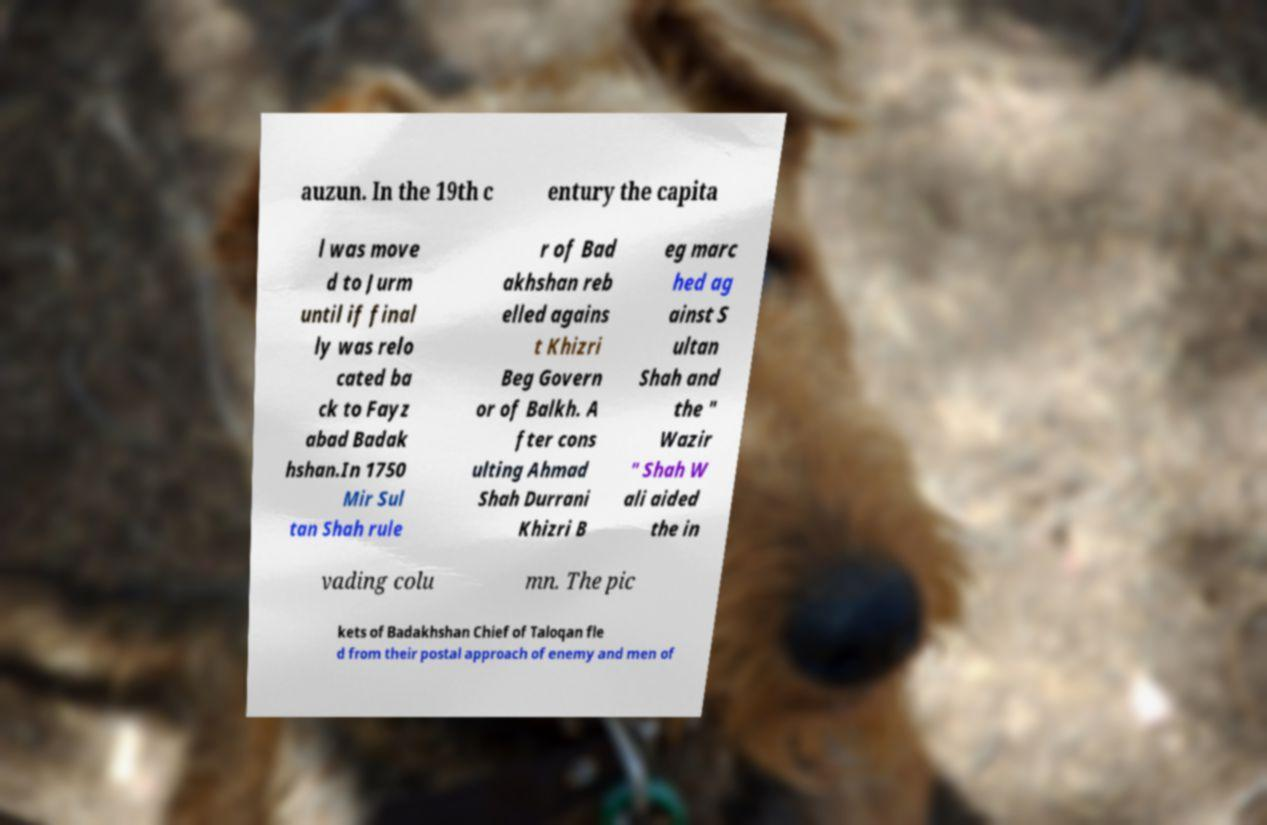Could you extract and type out the text from this image? auzun. In the 19th c entury the capita l was move d to Jurm until if final ly was relo cated ba ck to Fayz abad Badak hshan.In 1750 Mir Sul tan Shah rule r of Bad akhshan reb elled agains t Khizri Beg Govern or of Balkh. A fter cons ulting Ahmad Shah Durrani Khizri B eg marc hed ag ainst S ultan Shah and the " Wazir " Shah W ali aided the in vading colu mn. The pic kets of Badakhshan Chief of Taloqan fle d from their postal approach of enemy and men of 